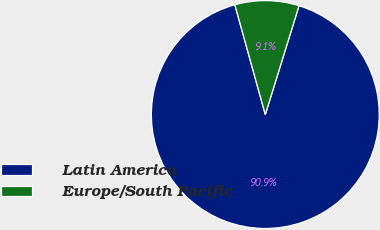Convert chart. <chart><loc_0><loc_0><loc_500><loc_500><pie_chart><fcel>Latin America<fcel>Europe/South Pacific<nl><fcel>90.91%<fcel>9.09%<nl></chart> 